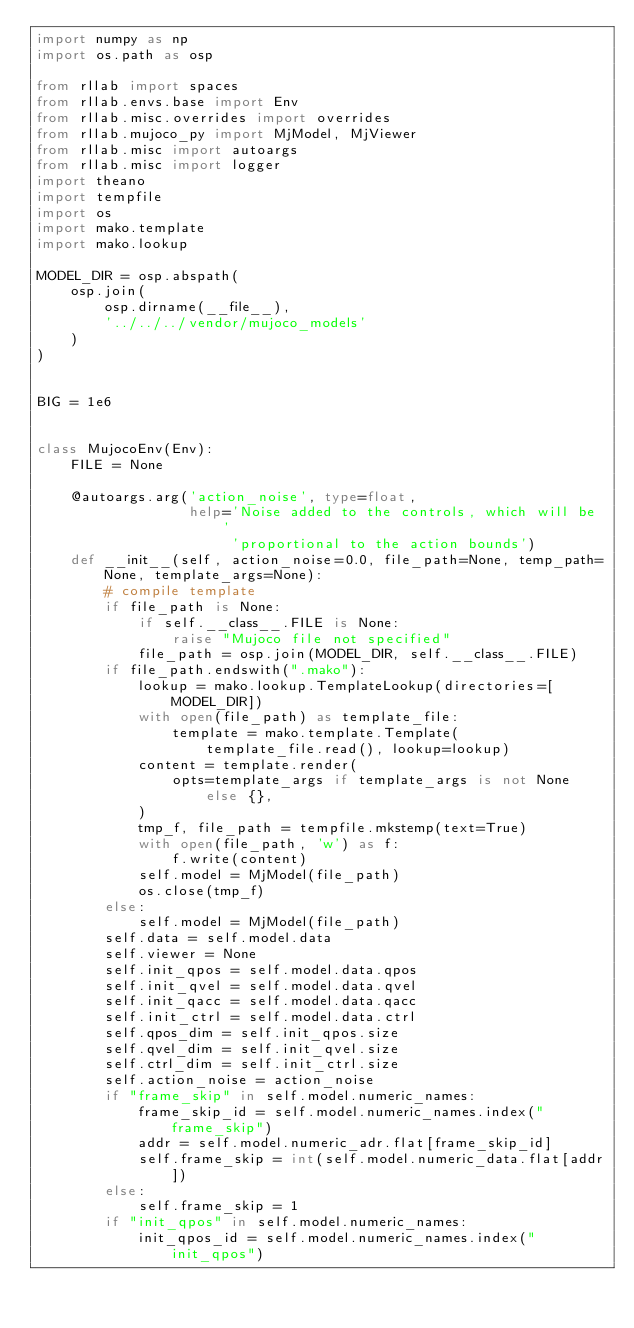<code> <loc_0><loc_0><loc_500><loc_500><_Python_>import numpy as np
import os.path as osp

from rllab import spaces
from rllab.envs.base import Env
from rllab.misc.overrides import overrides
from rllab.mujoco_py import MjModel, MjViewer
from rllab.misc import autoargs
from rllab.misc import logger
import theano
import tempfile
import os
import mako.template
import mako.lookup

MODEL_DIR = osp.abspath(
    osp.join(
        osp.dirname(__file__),
        '../../../vendor/mujoco_models'
    )
)


BIG = 1e6


class MujocoEnv(Env):
    FILE = None

    @autoargs.arg('action_noise', type=float,
                  help='Noise added to the controls, which will be '
                       'proportional to the action bounds')
    def __init__(self, action_noise=0.0, file_path=None, temp_path=None, template_args=None):
        # compile template
        if file_path is None:
            if self.__class__.FILE is None:
                raise "Mujoco file not specified"
            file_path = osp.join(MODEL_DIR, self.__class__.FILE)
        if file_path.endswith(".mako"):
            lookup = mako.lookup.TemplateLookup(directories=[MODEL_DIR])
            with open(file_path) as template_file:
                template = mako.template.Template(
                    template_file.read(), lookup=lookup)
            content = template.render(
                opts=template_args if template_args is not None else {},
            )
            tmp_f, file_path = tempfile.mkstemp(text=True)
            with open(file_path, 'w') as f:
                f.write(content)
            self.model = MjModel(file_path)
            os.close(tmp_f)
        else:
            self.model = MjModel(file_path)
        self.data = self.model.data
        self.viewer = None
        self.init_qpos = self.model.data.qpos
        self.init_qvel = self.model.data.qvel
        self.init_qacc = self.model.data.qacc
        self.init_ctrl = self.model.data.ctrl
        self.qpos_dim = self.init_qpos.size
        self.qvel_dim = self.init_qvel.size
        self.ctrl_dim = self.init_ctrl.size
        self.action_noise = action_noise
        if "frame_skip" in self.model.numeric_names:
            frame_skip_id = self.model.numeric_names.index("frame_skip")
            addr = self.model.numeric_adr.flat[frame_skip_id]
            self.frame_skip = int(self.model.numeric_data.flat[addr])
        else:
            self.frame_skip = 1
        if "init_qpos" in self.model.numeric_names:
            init_qpos_id = self.model.numeric_names.index("init_qpos")</code> 